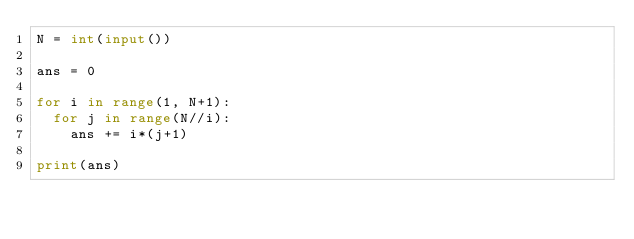Convert code to text. <code><loc_0><loc_0><loc_500><loc_500><_Python_>N = int(input())

ans = 0

for i in range(1, N+1):
  for j in range(N//i):
    ans += i*(j+1)

print(ans)
</code> 